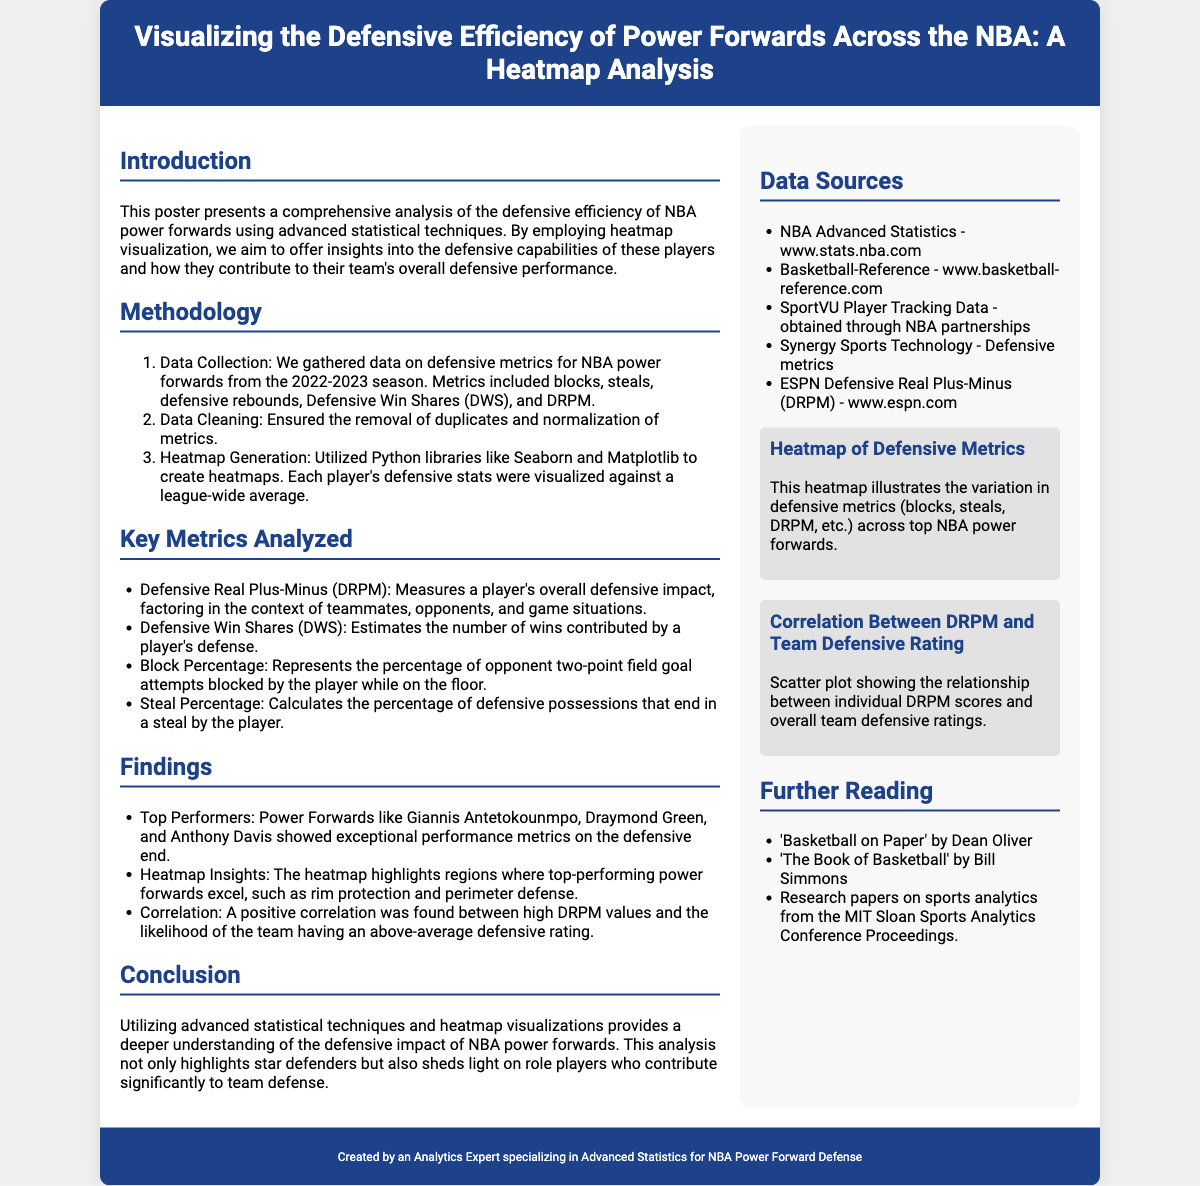What is the title of the poster? The title is presented prominently at the top of the poster.
Answer: Visualizing the Defensive Efficiency of Power Forwards Across the NBA: A Heatmap Analysis Which players are mentioned as top performers? The findings section lists specific players known for their defensive performance.
Answer: Giannis Antetokounmpo, Draymond Green, Anthony Davis What metric does DRPM stand for? This acronym is expanded in the key metrics section of the poster.
Answer: Defensive Real Plus-Minus How were data metrics collected? The methodology section explains the sources and procedure for data collection.
Answer: NBA power forwards from the 2022-2023 season What visualization technique was used to present the data? The methodology section describes the specific technique applied to create visuals.
Answer: Heatmap What correlation was found in the findings? The findings section highlights a specific relationship between metrics.
Answer: Positive correlation Which data source is listed first? The sources listed in the right column are in a specific order.
Answer: NBA Advanced Statistics - www.stats.nba.com What type of reading material is suggested for further reading? The further reading section lists types of resources for continued learning.
Answer: Research papers on sports analytics What was emphasized as an outcome of the poster's analysis? The conclusion section summarizes the aim and result of the analysis.
Answer: Deeper understanding of defensive impact 